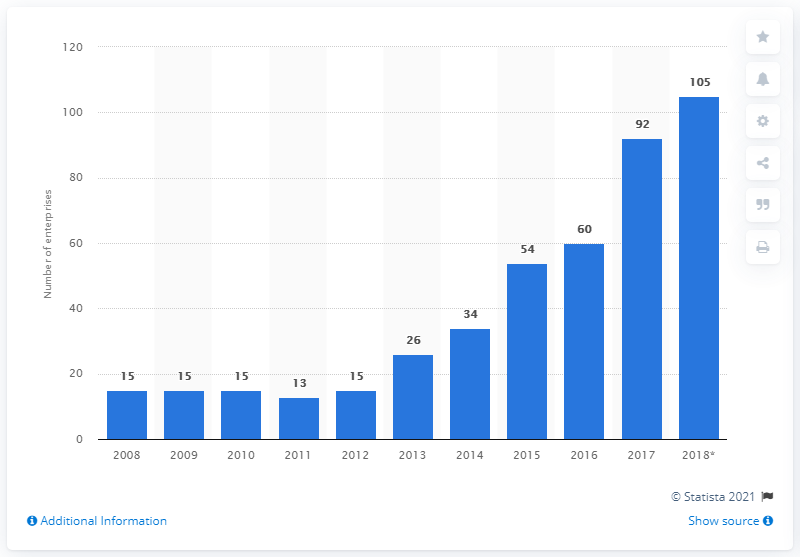Identify some key points in this picture. In 2017, there were 92 enterprises in Lithuania that were primarily engaged in manufacturing games and toys. 